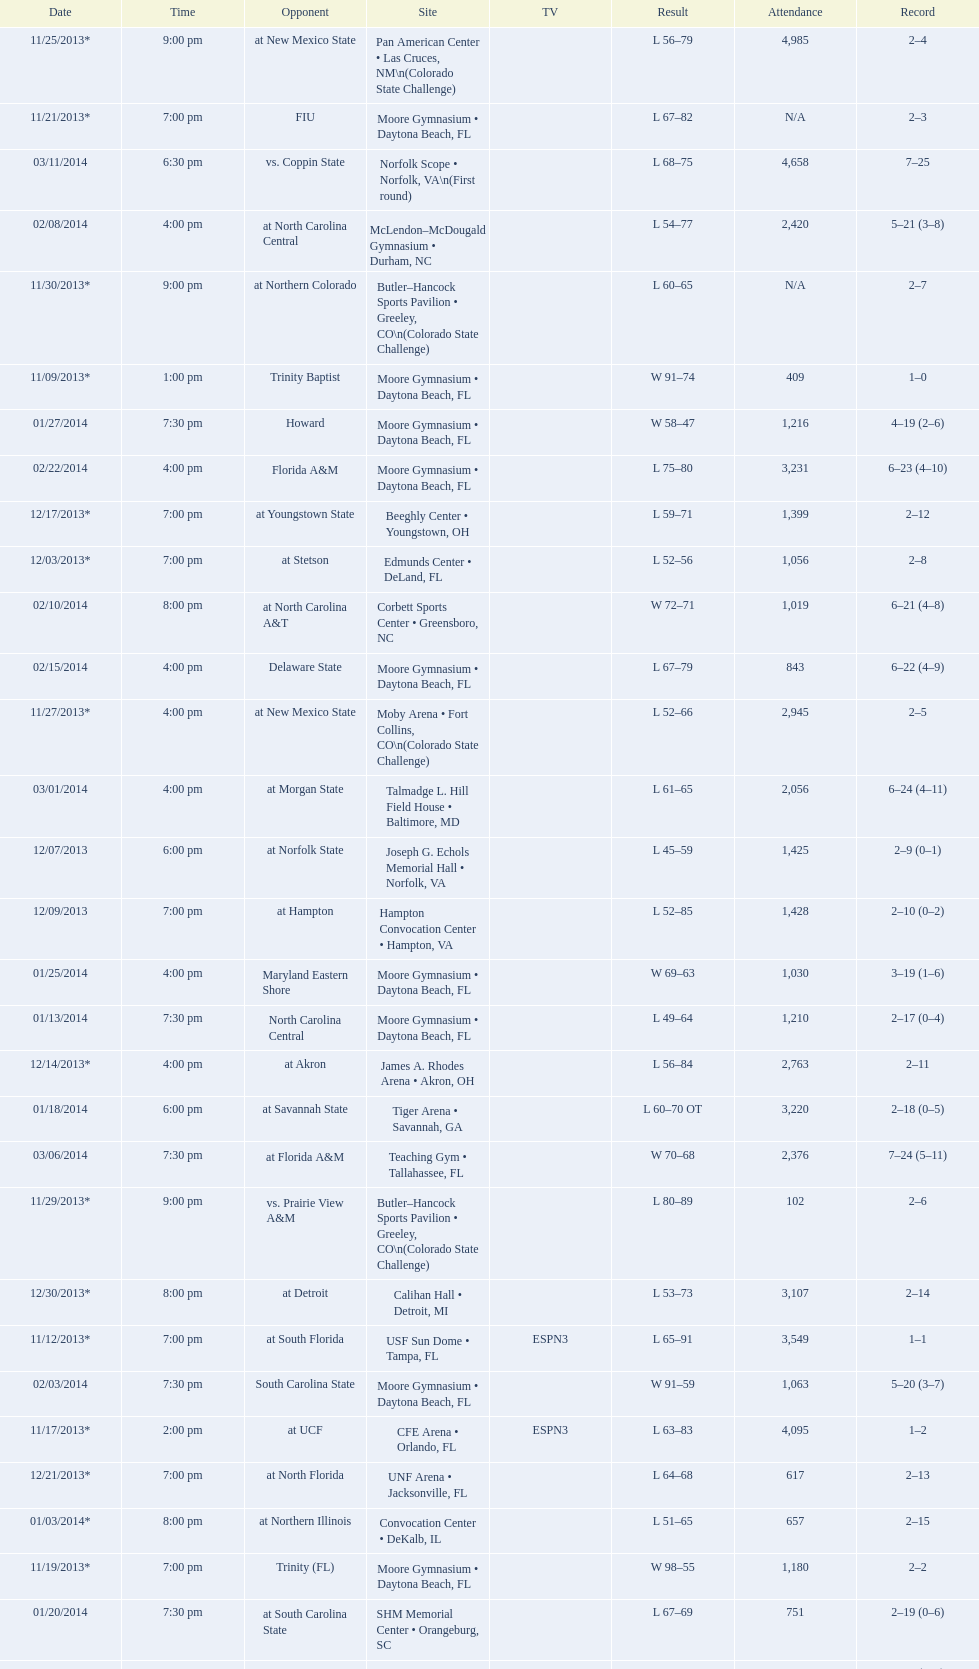Which game was later at night, fiu or northern colorado? Northern Colorado. 